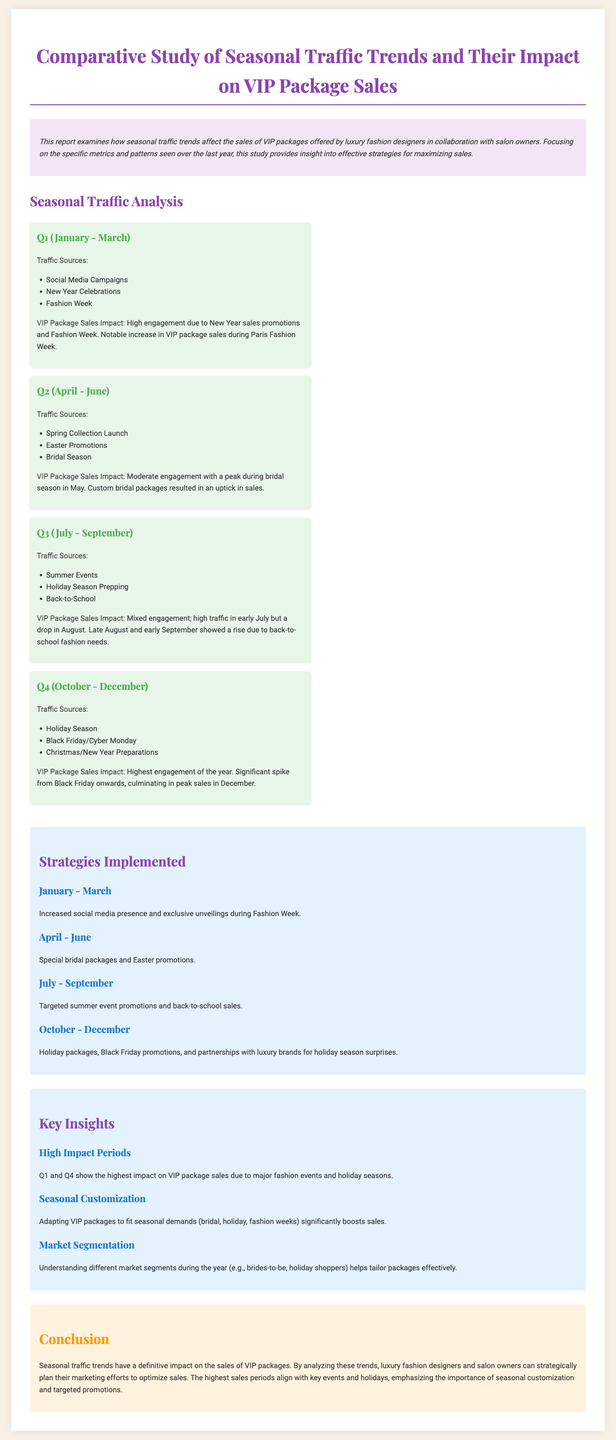What is the highest month for VIP package sales? The report states that the highest engagement and sales occur in December, especially during the holiday season.
Answer: December Which quarter shows a notable increase in sales during Fashion Week? The data indicates that Q1 experiences a significant rise in VIP package sales during Paris Fashion Week.
Answer: Q1 What promotional strategy was highlighted for Q2? The document mentions special bridal packages and Easter promotions implemented during the second quarter.
Answer: Special bridal packages What traffic source is mentioned as significant in Q3? Summer events are noted as major traffic sources for the third quarter in the report.
Answer: Summer Events Which two quarters have the highest impact on VIP package sales? Q1 and Q4 are indicated to show the highest impact due to major fashion events and holidays.
Answer: Q1 and Q4 What is the peak sales period for VIP packages? The analysis reveals that peak sales occur from Black Friday onward, culminating in December.
Answer: Black Friday What season begins with a high traffic from New Year celebrations? The document states that Q1 starts with high engagement from New Year celebrations.
Answer: Q1 What strategy was used in Q3 to boost package sales? The report specifies targeted summer event promotions to enhance sales during the summer quarter.
Answer: Targeted summer event promotions 